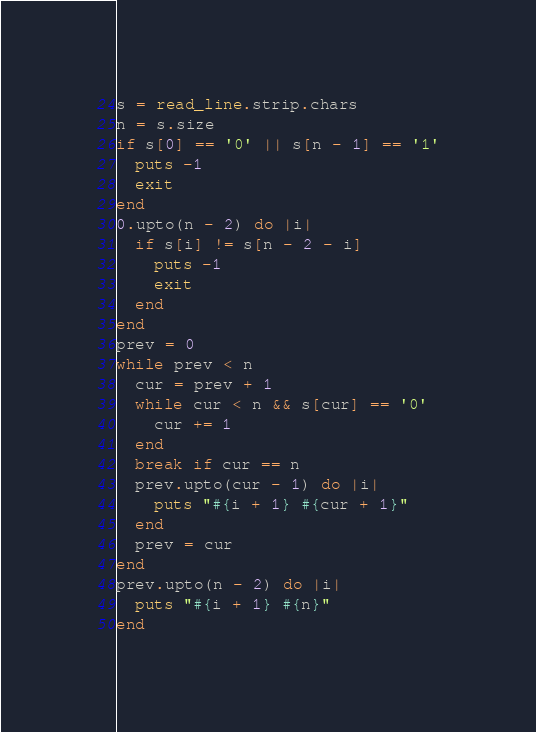<code> <loc_0><loc_0><loc_500><loc_500><_Crystal_>s = read_line.strip.chars
n = s.size
if s[0] == '0' || s[n - 1] == '1'
  puts -1
  exit
end
0.upto(n - 2) do |i|
  if s[i] != s[n - 2 - i]
    puts -1
    exit
  end
end
prev = 0
while prev < n
  cur = prev + 1
  while cur < n && s[cur] == '0'
    cur += 1
  end
  break if cur == n
  prev.upto(cur - 1) do |i|
    puts "#{i + 1} #{cur + 1}"
  end
  prev = cur
end
prev.upto(n - 2) do |i|
  puts "#{i + 1} #{n}"
end
</code> 